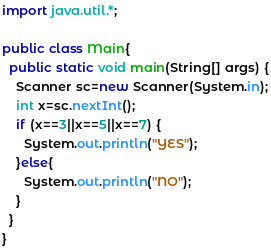<code> <loc_0><loc_0><loc_500><loc_500><_Java_>import java.util.*;

public class Main{
  public static void main(String[] args) {
    Scanner sc=new Scanner(System.in);
    int x=sc.nextInt();
    if (x==3||x==5||x==7) {
      System.out.println("YES");
    }else{
      System.out.println("NO");
    }
  }
}
</code> 